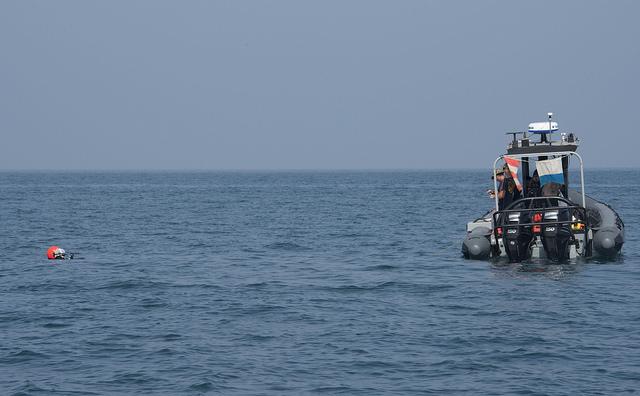What is the little object in the water?
Concise answer only. Buoy. What is the boat used for?
Answer briefly. Fishing. Is there anything on the horizon?
Answer briefly. No. Is the water deeper than six feet?
Concise answer only. Yes. How many birds in the shot?
Concise answer only. 0. 